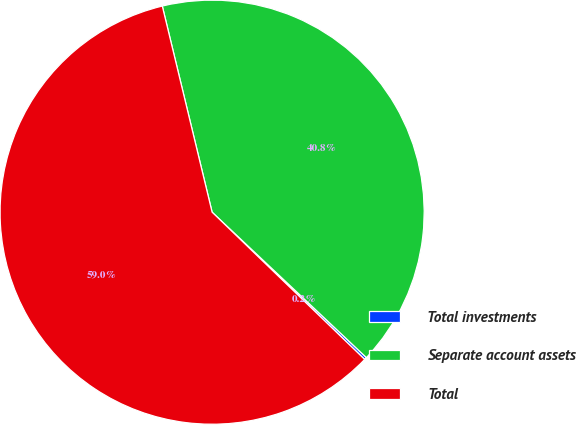Convert chart. <chart><loc_0><loc_0><loc_500><loc_500><pie_chart><fcel>Total investments<fcel>Separate account assets<fcel>Total<nl><fcel>0.19%<fcel>40.8%<fcel>59.0%<nl></chart> 